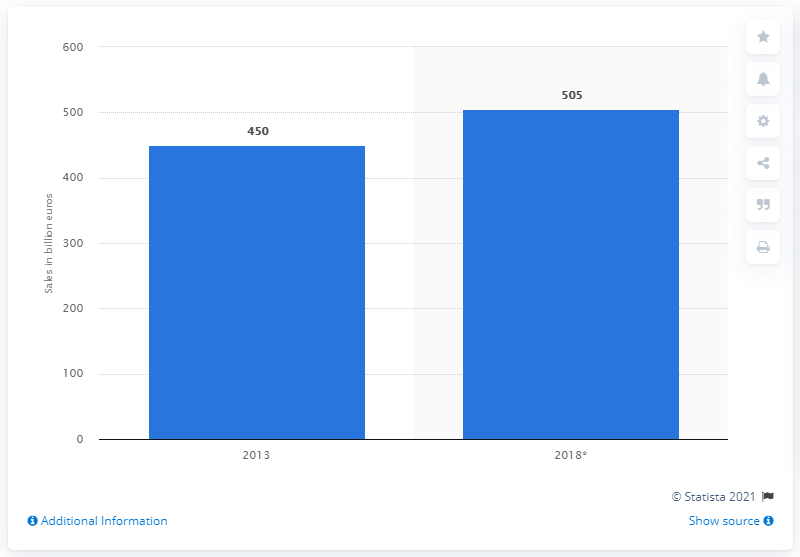Highlight a few significant elements in this photo. The expected growth of retail sales in Germany in 2018 is 50.5%. In 2013, the total value of retail sales in Germany was approximately 450,000. In 2013, retail sales in Germany reached an unprecedented 450 billion euros. 